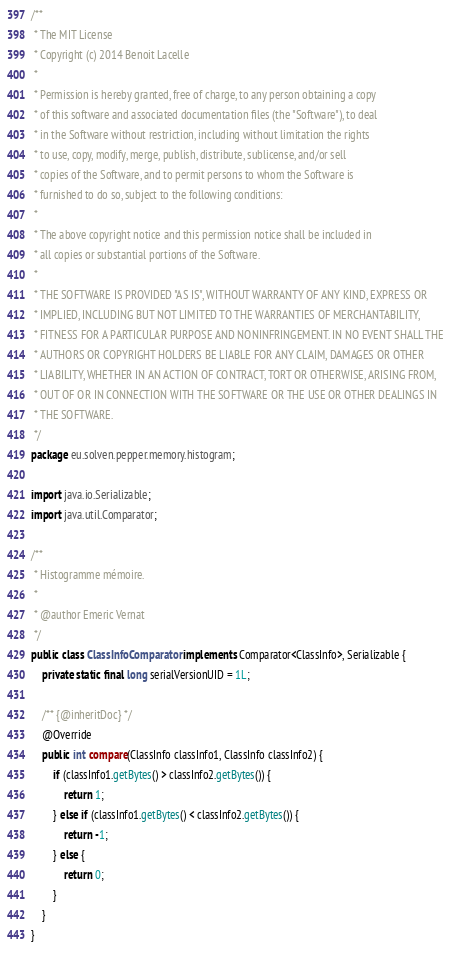Convert code to text. <code><loc_0><loc_0><loc_500><loc_500><_Java_>/**
 * The MIT License
 * Copyright (c) 2014 Benoit Lacelle
 *
 * Permission is hereby granted, free of charge, to any person obtaining a copy
 * of this software and associated documentation files (the "Software"), to deal
 * in the Software without restriction, including without limitation the rights
 * to use, copy, modify, merge, publish, distribute, sublicense, and/or sell
 * copies of the Software, and to permit persons to whom the Software is
 * furnished to do so, subject to the following conditions:
 *
 * The above copyright notice and this permission notice shall be included in
 * all copies or substantial portions of the Software.
 *
 * THE SOFTWARE IS PROVIDED "AS IS", WITHOUT WARRANTY OF ANY KIND, EXPRESS OR
 * IMPLIED, INCLUDING BUT NOT LIMITED TO THE WARRANTIES OF MERCHANTABILITY,
 * FITNESS FOR A PARTICULAR PURPOSE AND NONINFRINGEMENT. IN NO EVENT SHALL THE
 * AUTHORS OR COPYRIGHT HOLDERS BE LIABLE FOR ANY CLAIM, DAMAGES OR OTHER
 * LIABILITY, WHETHER IN AN ACTION OF CONTRACT, TORT OR OTHERWISE, ARISING FROM,
 * OUT OF OR IN CONNECTION WITH THE SOFTWARE OR THE USE OR OTHER DEALINGS IN
 * THE SOFTWARE.
 */
package eu.solven.pepper.memory.histogram;

import java.io.Serializable;
import java.util.Comparator;

/**
 * Histogramme mémoire.
 * 
 * @author Emeric Vernat
 */
public class ClassInfoComparator implements Comparator<ClassInfo>, Serializable {
	private static final long serialVersionUID = 1L;

	/** {@inheritDoc} */
	@Override
	public int compare(ClassInfo classInfo1, ClassInfo classInfo2) {
		if (classInfo1.getBytes() > classInfo2.getBytes()) {
			return 1;
		} else if (classInfo1.getBytes() < classInfo2.getBytes()) {
			return -1;
		} else {
			return 0;
		}
	}
}</code> 